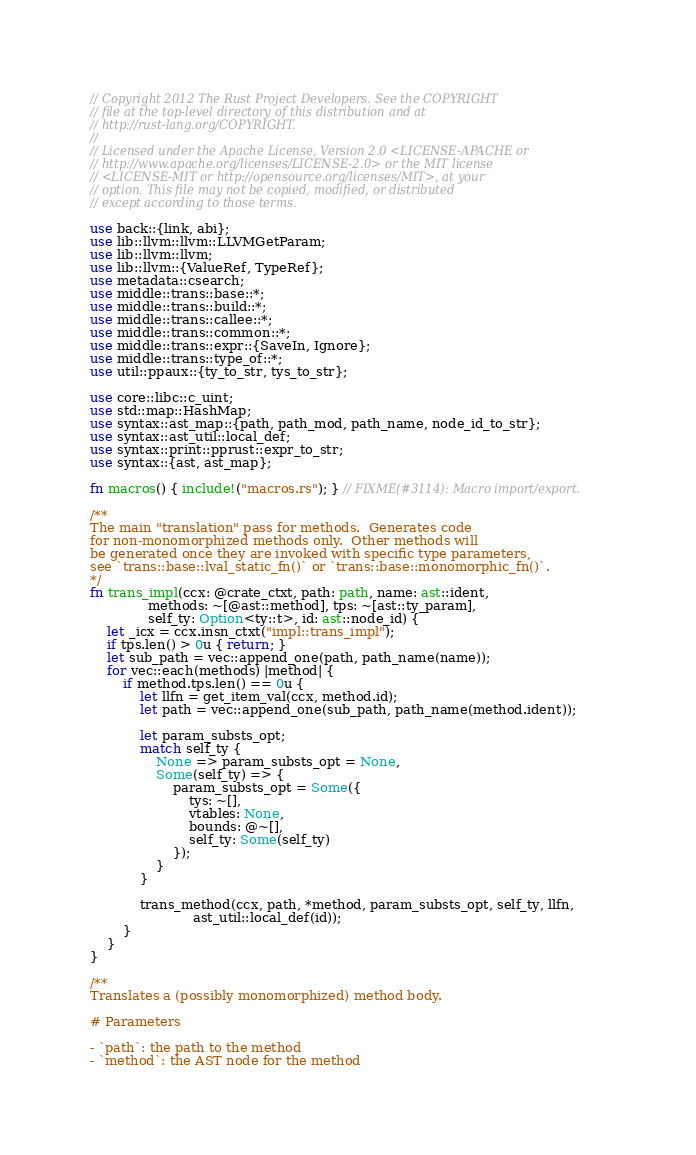Convert code to text. <code><loc_0><loc_0><loc_500><loc_500><_Rust_>// Copyright 2012 The Rust Project Developers. See the COPYRIGHT
// file at the top-level directory of this distribution and at
// http://rust-lang.org/COPYRIGHT.
//
// Licensed under the Apache License, Version 2.0 <LICENSE-APACHE or
// http://www.apache.org/licenses/LICENSE-2.0> or the MIT license
// <LICENSE-MIT or http://opensource.org/licenses/MIT>, at your
// option. This file may not be copied, modified, or distributed
// except according to those terms.

use back::{link, abi};
use lib::llvm::llvm::LLVMGetParam;
use lib::llvm::llvm;
use lib::llvm::{ValueRef, TypeRef};
use metadata::csearch;
use middle::trans::base::*;
use middle::trans::build::*;
use middle::trans::callee::*;
use middle::trans::common::*;
use middle::trans::expr::{SaveIn, Ignore};
use middle::trans::type_of::*;
use util::ppaux::{ty_to_str, tys_to_str};

use core::libc::c_uint;
use std::map::HashMap;
use syntax::ast_map::{path, path_mod, path_name, node_id_to_str};
use syntax::ast_util::local_def;
use syntax::print::pprust::expr_to_str;
use syntax::{ast, ast_map};

fn macros() { include!("macros.rs"); } // FIXME(#3114): Macro import/export.

/**
The main "translation" pass for methods.  Generates code
for non-monomorphized methods only.  Other methods will
be generated once they are invoked with specific type parameters,
see `trans::base::lval_static_fn()` or `trans::base::monomorphic_fn()`.
*/
fn trans_impl(ccx: @crate_ctxt, path: path, name: ast::ident,
              methods: ~[@ast::method], tps: ~[ast::ty_param],
              self_ty: Option<ty::t>, id: ast::node_id) {
    let _icx = ccx.insn_ctxt("impl::trans_impl");
    if tps.len() > 0u { return; }
    let sub_path = vec::append_one(path, path_name(name));
    for vec::each(methods) |method| {
        if method.tps.len() == 0u {
            let llfn = get_item_val(ccx, method.id);
            let path = vec::append_one(sub_path, path_name(method.ident));

            let param_substs_opt;
            match self_ty {
                None => param_substs_opt = None,
                Some(self_ty) => {
                    param_substs_opt = Some({
                        tys: ~[],
                        vtables: None,
                        bounds: @~[],
                        self_ty: Some(self_ty)
                    });
                }
            }

            trans_method(ccx, path, *method, param_substs_opt, self_ty, llfn,
                         ast_util::local_def(id));
        }
    }
}

/**
Translates a (possibly monomorphized) method body.

# Parameters

- `path`: the path to the method
- `method`: the AST node for the method</code> 